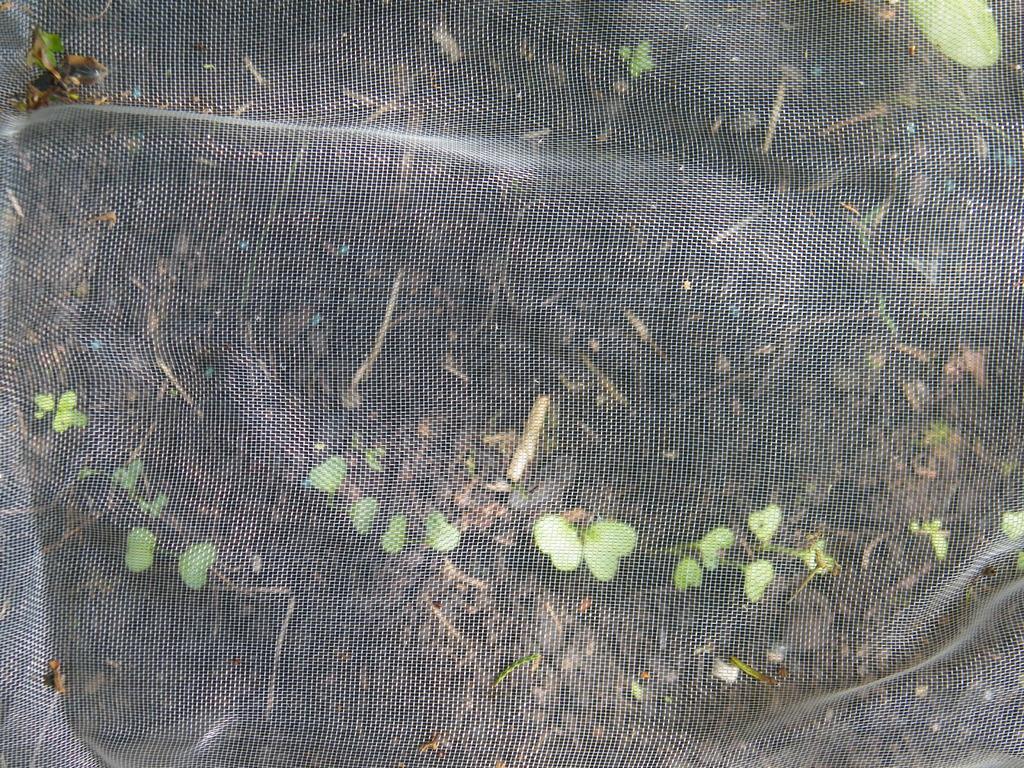In one or two sentences, can you explain what this image depicts? In this image I can see the plants on ground through a metal mesh. 